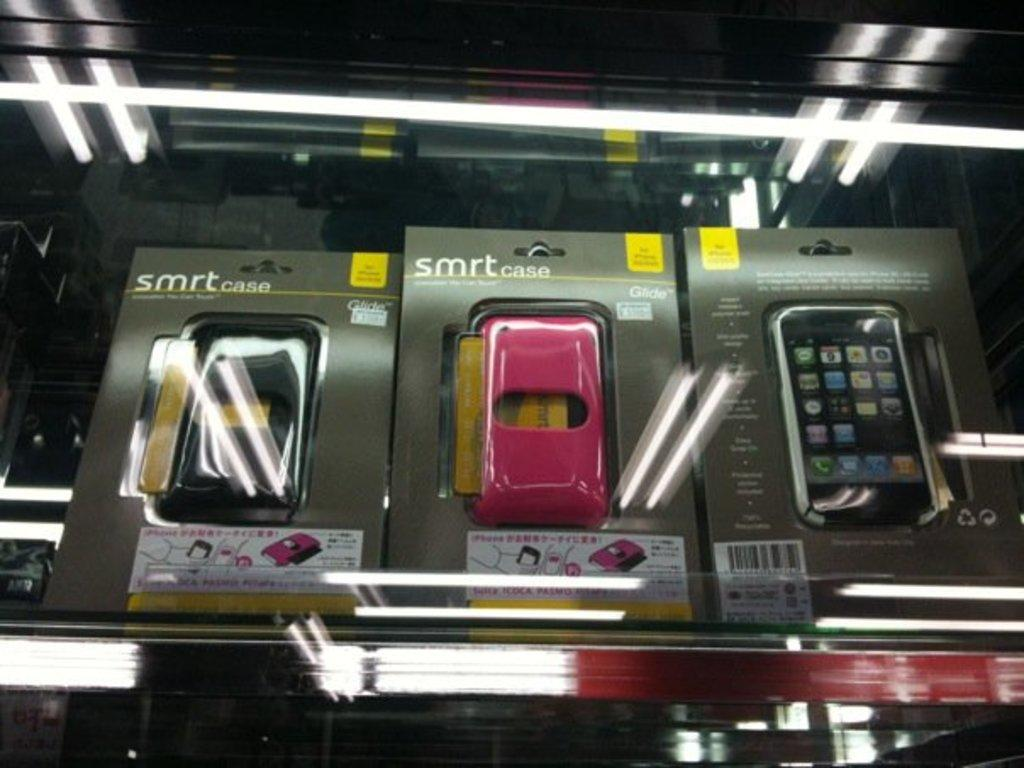Provide a one-sentence caption for the provided image. SMRT cases on the shelf are available in black and pink. 